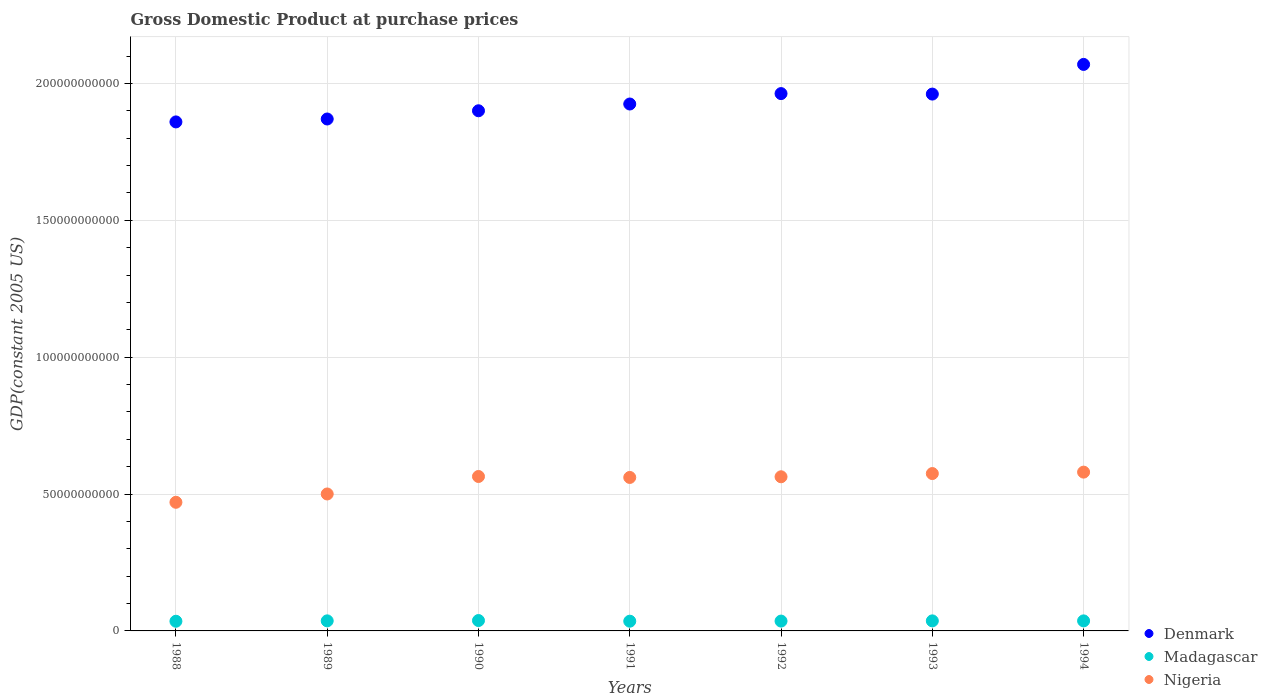How many different coloured dotlines are there?
Make the answer very short. 3. Is the number of dotlines equal to the number of legend labels?
Your answer should be very brief. Yes. What is the GDP at purchase prices in Nigeria in 1989?
Keep it short and to the point. 5.00e+1. Across all years, what is the maximum GDP at purchase prices in Nigeria?
Make the answer very short. 5.80e+1. Across all years, what is the minimum GDP at purchase prices in Madagascar?
Provide a short and direct response. 3.53e+09. In which year was the GDP at purchase prices in Madagascar maximum?
Your answer should be compact. 1990. What is the total GDP at purchase prices in Nigeria in the graph?
Offer a terse response. 3.81e+11. What is the difference between the GDP at purchase prices in Nigeria in 1988 and that in 1993?
Your answer should be compact. -1.05e+1. What is the difference between the GDP at purchase prices in Nigeria in 1994 and the GDP at purchase prices in Madagascar in 1992?
Your response must be concise. 5.44e+1. What is the average GDP at purchase prices in Denmark per year?
Your answer should be very brief. 1.94e+11. In the year 1992, what is the difference between the GDP at purchase prices in Nigeria and GDP at purchase prices in Denmark?
Keep it short and to the point. -1.40e+11. What is the ratio of the GDP at purchase prices in Nigeria in 1991 to that in 1992?
Your response must be concise. 1. Is the difference between the GDP at purchase prices in Nigeria in 1988 and 1990 greater than the difference between the GDP at purchase prices in Denmark in 1988 and 1990?
Offer a very short reply. No. What is the difference between the highest and the second highest GDP at purchase prices in Madagascar?
Keep it short and to the point. 1.15e+08. What is the difference between the highest and the lowest GDP at purchase prices in Denmark?
Give a very brief answer. 2.10e+1. In how many years, is the GDP at purchase prices in Madagascar greater than the average GDP at purchase prices in Madagascar taken over all years?
Provide a succinct answer. 4. Is the sum of the GDP at purchase prices in Nigeria in 1989 and 1992 greater than the maximum GDP at purchase prices in Denmark across all years?
Give a very brief answer. No. Is the GDP at purchase prices in Madagascar strictly greater than the GDP at purchase prices in Nigeria over the years?
Your answer should be compact. No. Is the GDP at purchase prices in Madagascar strictly less than the GDP at purchase prices in Nigeria over the years?
Provide a short and direct response. Yes. How many years are there in the graph?
Offer a terse response. 7. What is the difference between two consecutive major ticks on the Y-axis?
Provide a succinct answer. 5.00e+1. Does the graph contain grids?
Offer a very short reply. Yes. What is the title of the graph?
Offer a very short reply. Gross Domestic Product at purchase prices. Does "Pakistan" appear as one of the legend labels in the graph?
Provide a succinct answer. No. What is the label or title of the X-axis?
Keep it short and to the point. Years. What is the label or title of the Y-axis?
Provide a short and direct response. GDP(constant 2005 US). What is the GDP(constant 2005 US) in Denmark in 1988?
Give a very brief answer. 1.86e+11. What is the GDP(constant 2005 US) in Madagascar in 1988?
Give a very brief answer. 3.53e+09. What is the GDP(constant 2005 US) of Nigeria in 1988?
Ensure brevity in your answer.  4.70e+1. What is the GDP(constant 2005 US) in Denmark in 1989?
Offer a very short reply. 1.87e+11. What is the GDP(constant 2005 US) of Madagascar in 1989?
Your response must be concise. 3.68e+09. What is the GDP(constant 2005 US) in Nigeria in 1989?
Your response must be concise. 5.00e+1. What is the GDP(constant 2005 US) in Denmark in 1990?
Ensure brevity in your answer.  1.90e+11. What is the GDP(constant 2005 US) of Madagascar in 1990?
Ensure brevity in your answer.  3.79e+09. What is the GDP(constant 2005 US) in Nigeria in 1990?
Give a very brief answer. 5.64e+1. What is the GDP(constant 2005 US) of Denmark in 1991?
Offer a very short reply. 1.93e+11. What is the GDP(constant 2005 US) in Madagascar in 1991?
Ensure brevity in your answer.  3.55e+09. What is the GDP(constant 2005 US) in Nigeria in 1991?
Provide a succinct answer. 5.61e+1. What is the GDP(constant 2005 US) of Denmark in 1992?
Make the answer very short. 1.96e+11. What is the GDP(constant 2005 US) of Madagascar in 1992?
Your response must be concise. 3.60e+09. What is the GDP(constant 2005 US) of Nigeria in 1992?
Your answer should be very brief. 5.63e+1. What is the GDP(constant 2005 US) of Denmark in 1993?
Give a very brief answer. 1.96e+11. What is the GDP(constant 2005 US) in Madagascar in 1993?
Keep it short and to the point. 3.67e+09. What is the GDP(constant 2005 US) of Nigeria in 1993?
Offer a terse response. 5.75e+1. What is the GDP(constant 2005 US) of Denmark in 1994?
Your response must be concise. 2.07e+11. What is the GDP(constant 2005 US) of Madagascar in 1994?
Make the answer very short. 3.67e+09. What is the GDP(constant 2005 US) of Nigeria in 1994?
Keep it short and to the point. 5.80e+1. Across all years, what is the maximum GDP(constant 2005 US) in Denmark?
Provide a succinct answer. 2.07e+11. Across all years, what is the maximum GDP(constant 2005 US) of Madagascar?
Make the answer very short. 3.79e+09. Across all years, what is the maximum GDP(constant 2005 US) in Nigeria?
Your answer should be very brief. 5.80e+1. Across all years, what is the minimum GDP(constant 2005 US) of Denmark?
Your response must be concise. 1.86e+11. Across all years, what is the minimum GDP(constant 2005 US) of Madagascar?
Provide a short and direct response. 3.53e+09. Across all years, what is the minimum GDP(constant 2005 US) in Nigeria?
Offer a very short reply. 4.70e+1. What is the total GDP(constant 2005 US) in Denmark in the graph?
Give a very brief answer. 1.35e+12. What is the total GDP(constant 2005 US) of Madagascar in the graph?
Provide a succinct answer. 2.55e+1. What is the total GDP(constant 2005 US) of Nigeria in the graph?
Give a very brief answer. 3.81e+11. What is the difference between the GDP(constant 2005 US) in Denmark in 1988 and that in 1989?
Your answer should be compact. -1.07e+09. What is the difference between the GDP(constant 2005 US) of Madagascar in 1988 and that in 1989?
Your answer should be very brief. -1.44e+08. What is the difference between the GDP(constant 2005 US) in Nigeria in 1988 and that in 1989?
Ensure brevity in your answer.  -3.04e+09. What is the difference between the GDP(constant 2005 US) of Denmark in 1988 and that in 1990?
Your answer should be very brief. -4.07e+09. What is the difference between the GDP(constant 2005 US) in Madagascar in 1988 and that in 1990?
Offer a very short reply. -2.59e+08. What is the difference between the GDP(constant 2005 US) of Nigeria in 1988 and that in 1990?
Ensure brevity in your answer.  -9.43e+09. What is the difference between the GDP(constant 2005 US) of Denmark in 1988 and that in 1991?
Make the answer very short. -6.54e+09. What is the difference between the GDP(constant 2005 US) in Madagascar in 1988 and that in 1991?
Offer a terse response. -1.99e+07. What is the difference between the GDP(constant 2005 US) of Nigeria in 1988 and that in 1991?
Your response must be concise. -9.08e+09. What is the difference between the GDP(constant 2005 US) of Denmark in 1988 and that in 1992?
Your response must be concise. -1.03e+1. What is the difference between the GDP(constant 2005 US) in Madagascar in 1988 and that in 1992?
Ensure brevity in your answer.  -6.21e+07. What is the difference between the GDP(constant 2005 US) in Nigeria in 1988 and that in 1992?
Provide a succinct answer. -9.32e+09. What is the difference between the GDP(constant 2005 US) of Denmark in 1988 and that in 1993?
Offer a terse response. -1.02e+1. What is the difference between the GDP(constant 2005 US) of Madagascar in 1988 and that in 1993?
Give a very brief answer. -1.37e+08. What is the difference between the GDP(constant 2005 US) in Nigeria in 1988 and that in 1993?
Your response must be concise. -1.05e+1. What is the difference between the GDP(constant 2005 US) of Denmark in 1988 and that in 1994?
Provide a short and direct response. -2.10e+1. What is the difference between the GDP(constant 2005 US) of Madagascar in 1988 and that in 1994?
Your response must be concise. -1.35e+08. What is the difference between the GDP(constant 2005 US) of Nigeria in 1988 and that in 1994?
Keep it short and to the point. -1.10e+1. What is the difference between the GDP(constant 2005 US) in Denmark in 1989 and that in 1990?
Give a very brief answer. -3.01e+09. What is the difference between the GDP(constant 2005 US) in Madagascar in 1989 and that in 1990?
Ensure brevity in your answer.  -1.15e+08. What is the difference between the GDP(constant 2005 US) of Nigeria in 1989 and that in 1990?
Your response must be concise. -6.39e+09. What is the difference between the GDP(constant 2005 US) in Denmark in 1989 and that in 1991?
Offer a very short reply. -5.48e+09. What is the difference between the GDP(constant 2005 US) of Madagascar in 1989 and that in 1991?
Ensure brevity in your answer.  1.24e+08. What is the difference between the GDP(constant 2005 US) in Nigeria in 1989 and that in 1991?
Your answer should be compact. -6.04e+09. What is the difference between the GDP(constant 2005 US) of Denmark in 1989 and that in 1992?
Your response must be concise. -9.28e+09. What is the difference between the GDP(constant 2005 US) of Madagascar in 1989 and that in 1992?
Your response must be concise. 8.20e+07. What is the difference between the GDP(constant 2005 US) of Nigeria in 1989 and that in 1992?
Provide a succinct answer. -6.28e+09. What is the difference between the GDP(constant 2005 US) in Denmark in 1989 and that in 1993?
Keep it short and to the point. -9.10e+09. What is the difference between the GDP(constant 2005 US) in Madagascar in 1989 and that in 1993?
Your answer should be compact. 6.66e+06. What is the difference between the GDP(constant 2005 US) in Nigeria in 1989 and that in 1993?
Ensure brevity in your answer.  -7.46e+09. What is the difference between the GDP(constant 2005 US) in Denmark in 1989 and that in 1994?
Provide a succinct answer. -1.99e+1. What is the difference between the GDP(constant 2005 US) in Madagascar in 1989 and that in 1994?
Provide a succinct answer. 9.29e+06. What is the difference between the GDP(constant 2005 US) in Nigeria in 1989 and that in 1994?
Your response must be concise. -7.98e+09. What is the difference between the GDP(constant 2005 US) of Denmark in 1990 and that in 1991?
Provide a succinct answer. -2.47e+09. What is the difference between the GDP(constant 2005 US) in Madagascar in 1990 and that in 1991?
Provide a succinct answer. 2.39e+08. What is the difference between the GDP(constant 2005 US) of Nigeria in 1990 and that in 1991?
Make the answer very short. 3.49e+08. What is the difference between the GDP(constant 2005 US) in Denmark in 1990 and that in 1992?
Provide a succinct answer. -6.27e+09. What is the difference between the GDP(constant 2005 US) in Madagascar in 1990 and that in 1992?
Your response must be concise. 1.97e+08. What is the difference between the GDP(constant 2005 US) in Nigeria in 1990 and that in 1992?
Your response must be concise. 1.05e+08. What is the difference between the GDP(constant 2005 US) in Denmark in 1990 and that in 1993?
Make the answer very short. -6.10e+09. What is the difference between the GDP(constant 2005 US) of Madagascar in 1990 and that in 1993?
Make the answer very short. 1.22e+08. What is the difference between the GDP(constant 2005 US) of Nigeria in 1990 and that in 1993?
Your response must be concise. -1.07e+09. What is the difference between the GDP(constant 2005 US) in Denmark in 1990 and that in 1994?
Ensure brevity in your answer.  -1.69e+1. What is the difference between the GDP(constant 2005 US) of Madagascar in 1990 and that in 1994?
Your answer should be very brief. 1.24e+08. What is the difference between the GDP(constant 2005 US) in Nigeria in 1990 and that in 1994?
Give a very brief answer. -1.59e+09. What is the difference between the GDP(constant 2005 US) of Denmark in 1991 and that in 1992?
Your answer should be very brief. -3.80e+09. What is the difference between the GDP(constant 2005 US) in Madagascar in 1991 and that in 1992?
Provide a succinct answer. -4.21e+07. What is the difference between the GDP(constant 2005 US) in Nigeria in 1991 and that in 1992?
Provide a succinct answer. -2.43e+08. What is the difference between the GDP(constant 2005 US) in Denmark in 1991 and that in 1993?
Provide a succinct answer. -3.63e+09. What is the difference between the GDP(constant 2005 US) in Madagascar in 1991 and that in 1993?
Ensure brevity in your answer.  -1.18e+08. What is the difference between the GDP(constant 2005 US) of Nigeria in 1991 and that in 1993?
Your answer should be compact. -1.42e+09. What is the difference between the GDP(constant 2005 US) in Denmark in 1991 and that in 1994?
Give a very brief answer. -1.45e+1. What is the difference between the GDP(constant 2005 US) of Madagascar in 1991 and that in 1994?
Your answer should be compact. -1.15e+08. What is the difference between the GDP(constant 2005 US) of Nigeria in 1991 and that in 1994?
Make the answer very short. -1.94e+09. What is the difference between the GDP(constant 2005 US) in Denmark in 1992 and that in 1993?
Keep it short and to the point. 1.76e+08. What is the difference between the GDP(constant 2005 US) in Madagascar in 1992 and that in 1993?
Make the answer very short. -7.54e+07. What is the difference between the GDP(constant 2005 US) of Nigeria in 1992 and that in 1993?
Your answer should be compact. -1.18e+09. What is the difference between the GDP(constant 2005 US) in Denmark in 1992 and that in 1994?
Provide a succinct answer. -1.07e+1. What is the difference between the GDP(constant 2005 US) of Madagascar in 1992 and that in 1994?
Provide a short and direct response. -7.27e+07. What is the difference between the GDP(constant 2005 US) in Nigeria in 1992 and that in 1994?
Your answer should be compact. -1.70e+09. What is the difference between the GDP(constant 2005 US) in Denmark in 1993 and that in 1994?
Offer a very short reply. -1.08e+1. What is the difference between the GDP(constant 2005 US) in Madagascar in 1993 and that in 1994?
Make the answer very short. 2.63e+06. What is the difference between the GDP(constant 2005 US) in Nigeria in 1993 and that in 1994?
Offer a terse response. -5.23e+08. What is the difference between the GDP(constant 2005 US) of Denmark in 1988 and the GDP(constant 2005 US) of Madagascar in 1989?
Provide a succinct answer. 1.82e+11. What is the difference between the GDP(constant 2005 US) in Denmark in 1988 and the GDP(constant 2005 US) in Nigeria in 1989?
Give a very brief answer. 1.36e+11. What is the difference between the GDP(constant 2005 US) in Madagascar in 1988 and the GDP(constant 2005 US) in Nigeria in 1989?
Provide a succinct answer. -4.65e+1. What is the difference between the GDP(constant 2005 US) in Denmark in 1988 and the GDP(constant 2005 US) in Madagascar in 1990?
Give a very brief answer. 1.82e+11. What is the difference between the GDP(constant 2005 US) of Denmark in 1988 and the GDP(constant 2005 US) of Nigeria in 1990?
Your response must be concise. 1.30e+11. What is the difference between the GDP(constant 2005 US) in Madagascar in 1988 and the GDP(constant 2005 US) in Nigeria in 1990?
Keep it short and to the point. -5.29e+1. What is the difference between the GDP(constant 2005 US) in Denmark in 1988 and the GDP(constant 2005 US) in Madagascar in 1991?
Ensure brevity in your answer.  1.82e+11. What is the difference between the GDP(constant 2005 US) in Denmark in 1988 and the GDP(constant 2005 US) in Nigeria in 1991?
Provide a succinct answer. 1.30e+11. What is the difference between the GDP(constant 2005 US) of Madagascar in 1988 and the GDP(constant 2005 US) of Nigeria in 1991?
Your answer should be very brief. -5.25e+1. What is the difference between the GDP(constant 2005 US) of Denmark in 1988 and the GDP(constant 2005 US) of Madagascar in 1992?
Ensure brevity in your answer.  1.82e+11. What is the difference between the GDP(constant 2005 US) of Denmark in 1988 and the GDP(constant 2005 US) of Nigeria in 1992?
Give a very brief answer. 1.30e+11. What is the difference between the GDP(constant 2005 US) in Madagascar in 1988 and the GDP(constant 2005 US) in Nigeria in 1992?
Keep it short and to the point. -5.28e+1. What is the difference between the GDP(constant 2005 US) of Denmark in 1988 and the GDP(constant 2005 US) of Madagascar in 1993?
Offer a terse response. 1.82e+11. What is the difference between the GDP(constant 2005 US) in Denmark in 1988 and the GDP(constant 2005 US) in Nigeria in 1993?
Your answer should be very brief. 1.28e+11. What is the difference between the GDP(constant 2005 US) in Madagascar in 1988 and the GDP(constant 2005 US) in Nigeria in 1993?
Your response must be concise. -5.40e+1. What is the difference between the GDP(constant 2005 US) of Denmark in 1988 and the GDP(constant 2005 US) of Madagascar in 1994?
Give a very brief answer. 1.82e+11. What is the difference between the GDP(constant 2005 US) in Denmark in 1988 and the GDP(constant 2005 US) in Nigeria in 1994?
Your response must be concise. 1.28e+11. What is the difference between the GDP(constant 2005 US) in Madagascar in 1988 and the GDP(constant 2005 US) in Nigeria in 1994?
Offer a very short reply. -5.45e+1. What is the difference between the GDP(constant 2005 US) of Denmark in 1989 and the GDP(constant 2005 US) of Madagascar in 1990?
Your answer should be very brief. 1.83e+11. What is the difference between the GDP(constant 2005 US) of Denmark in 1989 and the GDP(constant 2005 US) of Nigeria in 1990?
Provide a succinct answer. 1.31e+11. What is the difference between the GDP(constant 2005 US) in Madagascar in 1989 and the GDP(constant 2005 US) in Nigeria in 1990?
Ensure brevity in your answer.  -5.27e+1. What is the difference between the GDP(constant 2005 US) in Denmark in 1989 and the GDP(constant 2005 US) in Madagascar in 1991?
Offer a terse response. 1.83e+11. What is the difference between the GDP(constant 2005 US) of Denmark in 1989 and the GDP(constant 2005 US) of Nigeria in 1991?
Provide a short and direct response. 1.31e+11. What is the difference between the GDP(constant 2005 US) of Madagascar in 1989 and the GDP(constant 2005 US) of Nigeria in 1991?
Ensure brevity in your answer.  -5.24e+1. What is the difference between the GDP(constant 2005 US) in Denmark in 1989 and the GDP(constant 2005 US) in Madagascar in 1992?
Your answer should be very brief. 1.83e+11. What is the difference between the GDP(constant 2005 US) in Denmark in 1989 and the GDP(constant 2005 US) in Nigeria in 1992?
Give a very brief answer. 1.31e+11. What is the difference between the GDP(constant 2005 US) of Madagascar in 1989 and the GDP(constant 2005 US) of Nigeria in 1992?
Keep it short and to the point. -5.26e+1. What is the difference between the GDP(constant 2005 US) in Denmark in 1989 and the GDP(constant 2005 US) in Madagascar in 1993?
Offer a very short reply. 1.83e+11. What is the difference between the GDP(constant 2005 US) in Denmark in 1989 and the GDP(constant 2005 US) in Nigeria in 1993?
Your response must be concise. 1.30e+11. What is the difference between the GDP(constant 2005 US) in Madagascar in 1989 and the GDP(constant 2005 US) in Nigeria in 1993?
Provide a short and direct response. -5.38e+1. What is the difference between the GDP(constant 2005 US) in Denmark in 1989 and the GDP(constant 2005 US) in Madagascar in 1994?
Provide a short and direct response. 1.83e+11. What is the difference between the GDP(constant 2005 US) in Denmark in 1989 and the GDP(constant 2005 US) in Nigeria in 1994?
Provide a short and direct response. 1.29e+11. What is the difference between the GDP(constant 2005 US) of Madagascar in 1989 and the GDP(constant 2005 US) of Nigeria in 1994?
Ensure brevity in your answer.  -5.43e+1. What is the difference between the GDP(constant 2005 US) in Denmark in 1990 and the GDP(constant 2005 US) in Madagascar in 1991?
Keep it short and to the point. 1.86e+11. What is the difference between the GDP(constant 2005 US) in Denmark in 1990 and the GDP(constant 2005 US) in Nigeria in 1991?
Provide a short and direct response. 1.34e+11. What is the difference between the GDP(constant 2005 US) in Madagascar in 1990 and the GDP(constant 2005 US) in Nigeria in 1991?
Make the answer very short. -5.23e+1. What is the difference between the GDP(constant 2005 US) in Denmark in 1990 and the GDP(constant 2005 US) in Madagascar in 1992?
Your answer should be very brief. 1.86e+11. What is the difference between the GDP(constant 2005 US) of Denmark in 1990 and the GDP(constant 2005 US) of Nigeria in 1992?
Offer a terse response. 1.34e+11. What is the difference between the GDP(constant 2005 US) in Madagascar in 1990 and the GDP(constant 2005 US) in Nigeria in 1992?
Keep it short and to the point. -5.25e+1. What is the difference between the GDP(constant 2005 US) in Denmark in 1990 and the GDP(constant 2005 US) in Madagascar in 1993?
Keep it short and to the point. 1.86e+11. What is the difference between the GDP(constant 2005 US) in Denmark in 1990 and the GDP(constant 2005 US) in Nigeria in 1993?
Keep it short and to the point. 1.33e+11. What is the difference between the GDP(constant 2005 US) of Madagascar in 1990 and the GDP(constant 2005 US) of Nigeria in 1993?
Your answer should be compact. -5.37e+1. What is the difference between the GDP(constant 2005 US) of Denmark in 1990 and the GDP(constant 2005 US) of Madagascar in 1994?
Provide a short and direct response. 1.86e+11. What is the difference between the GDP(constant 2005 US) of Denmark in 1990 and the GDP(constant 2005 US) of Nigeria in 1994?
Keep it short and to the point. 1.32e+11. What is the difference between the GDP(constant 2005 US) of Madagascar in 1990 and the GDP(constant 2005 US) of Nigeria in 1994?
Provide a short and direct response. -5.42e+1. What is the difference between the GDP(constant 2005 US) of Denmark in 1991 and the GDP(constant 2005 US) of Madagascar in 1992?
Your answer should be very brief. 1.89e+11. What is the difference between the GDP(constant 2005 US) in Denmark in 1991 and the GDP(constant 2005 US) in Nigeria in 1992?
Provide a short and direct response. 1.36e+11. What is the difference between the GDP(constant 2005 US) in Madagascar in 1991 and the GDP(constant 2005 US) in Nigeria in 1992?
Make the answer very short. -5.28e+1. What is the difference between the GDP(constant 2005 US) of Denmark in 1991 and the GDP(constant 2005 US) of Madagascar in 1993?
Ensure brevity in your answer.  1.89e+11. What is the difference between the GDP(constant 2005 US) in Denmark in 1991 and the GDP(constant 2005 US) in Nigeria in 1993?
Keep it short and to the point. 1.35e+11. What is the difference between the GDP(constant 2005 US) in Madagascar in 1991 and the GDP(constant 2005 US) in Nigeria in 1993?
Provide a succinct answer. -5.39e+1. What is the difference between the GDP(constant 2005 US) in Denmark in 1991 and the GDP(constant 2005 US) in Madagascar in 1994?
Your answer should be very brief. 1.89e+11. What is the difference between the GDP(constant 2005 US) in Denmark in 1991 and the GDP(constant 2005 US) in Nigeria in 1994?
Offer a very short reply. 1.34e+11. What is the difference between the GDP(constant 2005 US) of Madagascar in 1991 and the GDP(constant 2005 US) of Nigeria in 1994?
Your answer should be compact. -5.45e+1. What is the difference between the GDP(constant 2005 US) of Denmark in 1992 and the GDP(constant 2005 US) of Madagascar in 1993?
Offer a very short reply. 1.93e+11. What is the difference between the GDP(constant 2005 US) of Denmark in 1992 and the GDP(constant 2005 US) of Nigeria in 1993?
Keep it short and to the point. 1.39e+11. What is the difference between the GDP(constant 2005 US) in Madagascar in 1992 and the GDP(constant 2005 US) in Nigeria in 1993?
Ensure brevity in your answer.  -5.39e+1. What is the difference between the GDP(constant 2005 US) in Denmark in 1992 and the GDP(constant 2005 US) in Madagascar in 1994?
Your answer should be very brief. 1.93e+11. What is the difference between the GDP(constant 2005 US) in Denmark in 1992 and the GDP(constant 2005 US) in Nigeria in 1994?
Keep it short and to the point. 1.38e+11. What is the difference between the GDP(constant 2005 US) in Madagascar in 1992 and the GDP(constant 2005 US) in Nigeria in 1994?
Make the answer very short. -5.44e+1. What is the difference between the GDP(constant 2005 US) of Denmark in 1993 and the GDP(constant 2005 US) of Madagascar in 1994?
Make the answer very short. 1.92e+11. What is the difference between the GDP(constant 2005 US) of Denmark in 1993 and the GDP(constant 2005 US) of Nigeria in 1994?
Offer a terse response. 1.38e+11. What is the difference between the GDP(constant 2005 US) in Madagascar in 1993 and the GDP(constant 2005 US) in Nigeria in 1994?
Give a very brief answer. -5.43e+1. What is the average GDP(constant 2005 US) in Denmark per year?
Ensure brevity in your answer.  1.94e+11. What is the average GDP(constant 2005 US) of Madagascar per year?
Keep it short and to the point. 3.64e+09. What is the average GDP(constant 2005 US) in Nigeria per year?
Provide a short and direct response. 5.45e+1. In the year 1988, what is the difference between the GDP(constant 2005 US) in Denmark and GDP(constant 2005 US) in Madagascar?
Your answer should be very brief. 1.82e+11. In the year 1988, what is the difference between the GDP(constant 2005 US) in Denmark and GDP(constant 2005 US) in Nigeria?
Your answer should be very brief. 1.39e+11. In the year 1988, what is the difference between the GDP(constant 2005 US) in Madagascar and GDP(constant 2005 US) in Nigeria?
Make the answer very short. -4.35e+1. In the year 1989, what is the difference between the GDP(constant 2005 US) in Denmark and GDP(constant 2005 US) in Madagascar?
Your answer should be very brief. 1.83e+11. In the year 1989, what is the difference between the GDP(constant 2005 US) of Denmark and GDP(constant 2005 US) of Nigeria?
Offer a terse response. 1.37e+11. In the year 1989, what is the difference between the GDP(constant 2005 US) of Madagascar and GDP(constant 2005 US) of Nigeria?
Your answer should be compact. -4.64e+1. In the year 1990, what is the difference between the GDP(constant 2005 US) in Denmark and GDP(constant 2005 US) in Madagascar?
Your answer should be very brief. 1.86e+11. In the year 1990, what is the difference between the GDP(constant 2005 US) in Denmark and GDP(constant 2005 US) in Nigeria?
Your answer should be very brief. 1.34e+11. In the year 1990, what is the difference between the GDP(constant 2005 US) in Madagascar and GDP(constant 2005 US) in Nigeria?
Provide a succinct answer. -5.26e+1. In the year 1991, what is the difference between the GDP(constant 2005 US) in Denmark and GDP(constant 2005 US) in Madagascar?
Make the answer very short. 1.89e+11. In the year 1991, what is the difference between the GDP(constant 2005 US) of Denmark and GDP(constant 2005 US) of Nigeria?
Give a very brief answer. 1.36e+11. In the year 1991, what is the difference between the GDP(constant 2005 US) of Madagascar and GDP(constant 2005 US) of Nigeria?
Provide a succinct answer. -5.25e+1. In the year 1992, what is the difference between the GDP(constant 2005 US) in Denmark and GDP(constant 2005 US) in Madagascar?
Make the answer very short. 1.93e+11. In the year 1992, what is the difference between the GDP(constant 2005 US) of Denmark and GDP(constant 2005 US) of Nigeria?
Provide a short and direct response. 1.40e+11. In the year 1992, what is the difference between the GDP(constant 2005 US) of Madagascar and GDP(constant 2005 US) of Nigeria?
Provide a short and direct response. -5.27e+1. In the year 1993, what is the difference between the GDP(constant 2005 US) in Denmark and GDP(constant 2005 US) in Madagascar?
Keep it short and to the point. 1.92e+11. In the year 1993, what is the difference between the GDP(constant 2005 US) of Denmark and GDP(constant 2005 US) of Nigeria?
Provide a short and direct response. 1.39e+11. In the year 1993, what is the difference between the GDP(constant 2005 US) in Madagascar and GDP(constant 2005 US) in Nigeria?
Provide a succinct answer. -5.38e+1. In the year 1994, what is the difference between the GDP(constant 2005 US) of Denmark and GDP(constant 2005 US) of Madagascar?
Your answer should be compact. 2.03e+11. In the year 1994, what is the difference between the GDP(constant 2005 US) in Denmark and GDP(constant 2005 US) in Nigeria?
Provide a succinct answer. 1.49e+11. In the year 1994, what is the difference between the GDP(constant 2005 US) in Madagascar and GDP(constant 2005 US) in Nigeria?
Provide a succinct answer. -5.43e+1. What is the ratio of the GDP(constant 2005 US) in Madagascar in 1988 to that in 1989?
Your response must be concise. 0.96. What is the ratio of the GDP(constant 2005 US) in Nigeria in 1988 to that in 1989?
Your response must be concise. 0.94. What is the ratio of the GDP(constant 2005 US) of Denmark in 1988 to that in 1990?
Give a very brief answer. 0.98. What is the ratio of the GDP(constant 2005 US) of Madagascar in 1988 to that in 1990?
Keep it short and to the point. 0.93. What is the ratio of the GDP(constant 2005 US) of Nigeria in 1988 to that in 1990?
Offer a very short reply. 0.83. What is the ratio of the GDP(constant 2005 US) in Madagascar in 1988 to that in 1991?
Offer a terse response. 0.99. What is the ratio of the GDP(constant 2005 US) in Nigeria in 1988 to that in 1991?
Ensure brevity in your answer.  0.84. What is the ratio of the GDP(constant 2005 US) in Denmark in 1988 to that in 1992?
Offer a very short reply. 0.95. What is the ratio of the GDP(constant 2005 US) in Madagascar in 1988 to that in 1992?
Give a very brief answer. 0.98. What is the ratio of the GDP(constant 2005 US) in Nigeria in 1988 to that in 1992?
Your answer should be very brief. 0.83. What is the ratio of the GDP(constant 2005 US) of Denmark in 1988 to that in 1993?
Ensure brevity in your answer.  0.95. What is the ratio of the GDP(constant 2005 US) of Madagascar in 1988 to that in 1993?
Make the answer very short. 0.96. What is the ratio of the GDP(constant 2005 US) of Nigeria in 1988 to that in 1993?
Keep it short and to the point. 0.82. What is the ratio of the GDP(constant 2005 US) of Denmark in 1988 to that in 1994?
Ensure brevity in your answer.  0.9. What is the ratio of the GDP(constant 2005 US) of Madagascar in 1988 to that in 1994?
Keep it short and to the point. 0.96. What is the ratio of the GDP(constant 2005 US) in Nigeria in 1988 to that in 1994?
Provide a short and direct response. 0.81. What is the ratio of the GDP(constant 2005 US) of Denmark in 1989 to that in 1990?
Offer a very short reply. 0.98. What is the ratio of the GDP(constant 2005 US) of Madagascar in 1989 to that in 1990?
Make the answer very short. 0.97. What is the ratio of the GDP(constant 2005 US) of Nigeria in 1989 to that in 1990?
Ensure brevity in your answer.  0.89. What is the ratio of the GDP(constant 2005 US) in Denmark in 1989 to that in 1991?
Provide a succinct answer. 0.97. What is the ratio of the GDP(constant 2005 US) in Madagascar in 1989 to that in 1991?
Give a very brief answer. 1.03. What is the ratio of the GDP(constant 2005 US) in Nigeria in 1989 to that in 1991?
Your answer should be very brief. 0.89. What is the ratio of the GDP(constant 2005 US) of Denmark in 1989 to that in 1992?
Make the answer very short. 0.95. What is the ratio of the GDP(constant 2005 US) in Madagascar in 1989 to that in 1992?
Your answer should be very brief. 1.02. What is the ratio of the GDP(constant 2005 US) in Nigeria in 1989 to that in 1992?
Offer a very short reply. 0.89. What is the ratio of the GDP(constant 2005 US) of Denmark in 1989 to that in 1993?
Keep it short and to the point. 0.95. What is the ratio of the GDP(constant 2005 US) of Nigeria in 1989 to that in 1993?
Give a very brief answer. 0.87. What is the ratio of the GDP(constant 2005 US) in Denmark in 1989 to that in 1994?
Offer a terse response. 0.9. What is the ratio of the GDP(constant 2005 US) in Nigeria in 1989 to that in 1994?
Give a very brief answer. 0.86. What is the ratio of the GDP(constant 2005 US) in Denmark in 1990 to that in 1991?
Your answer should be compact. 0.99. What is the ratio of the GDP(constant 2005 US) of Madagascar in 1990 to that in 1991?
Offer a very short reply. 1.07. What is the ratio of the GDP(constant 2005 US) of Nigeria in 1990 to that in 1991?
Your answer should be very brief. 1.01. What is the ratio of the GDP(constant 2005 US) of Madagascar in 1990 to that in 1992?
Give a very brief answer. 1.05. What is the ratio of the GDP(constant 2005 US) in Denmark in 1990 to that in 1993?
Keep it short and to the point. 0.97. What is the ratio of the GDP(constant 2005 US) of Madagascar in 1990 to that in 1993?
Provide a short and direct response. 1.03. What is the ratio of the GDP(constant 2005 US) in Nigeria in 1990 to that in 1993?
Your answer should be compact. 0.98. What is the ratio of the GDP(constant 2005 US) in Denmark in 1990 to that in 1994?
Give a very brief answer. 0.92. What is the ratio of the GDP(constant 2005 US) of Madagascar in 1990 to that in 1994?
Provide a succinct answer. 1.03. What is the ratio of the GDP(constant 2005 US) in Nigeria in 1990 to that in 1994?
Your answer should be compact. 0.97. What is the ratio of the GDP(constant 2005 US) in Denmark in 1991 to that in 1992?
Provide a short and direct response. 0.98. What is the ratio of the GDP(constant 2005 US) of Madagascar in 1991 to that in 1992?
Ensure brevity in your answer.  0.99. What is the ratio of the GDP(constant 2005 US) of Denmark in 1991 to that in 1993?
Make the answer very short. 0.98. What is the ratio of the GDP(constant 2005 US) in Madagascar in 1991 to that in 1993?
Provide a succinct answer. 0.97. What is the ratio of the GDP(constant 2005 US) in Nigeria in 1991 to that in 1993?
Ensure brevity in your answer.  0.98. What is the ratio of the GDP(constant 2005 US) in Denmark in 1991 to that in 1994?
Keep it short and to the point. 0.93. What is the ratio of the GDP(constant 2005 US) of Madagascar in 1991 to that in 1994?
Make the answer very short. 0.97. What is the ratio of the GDP(constant 2005 US) in Nigeria in 1991 to that in 1994?
Your answer should be compact. 0.97. What is the ratio of the GDP(constant 2005 US) of Denmark in 1992 to that in 1993?
Offer a very short reply. 1. What is the ratio of the GDP(constant 2005 US) in Madagascar in 1992 to that in 1993?
Make the answer very short. 0.98. What is the ratio of the GDP(constant 2005 US) of Nigeria in 1992 to that in 1993?
Keep it short and to the point. 0.98. What is the ratio of the GDP(constant 2005 US) in Denmark in 1992 to that in 1994?
Provide a short and direct response. 0.95. What is the ratio of the GDP(constant 2005 US) in Madagascar in 1992 to that in 1994?
Your answer should be very brief. 0.98. What is the ratio of the GDP(constant 2005 US) of Nigeria in 1992 to that in 1994?
Make the answer very short. 0.97. What is the ratio of the GDP(constant 2005 US) of Denmark in 1993 to that in 1994?
Provide a short and direct response. 0.95. What is the ratio of the GDP(constant 2005 US) of Madagascar in 1993 to that in 1994?
Your response must be concise. 1. What is the difference between the highest and the second highest GDP(constant 2005 US) of Denmark?
Provide a short and direct response. 1.07e+1. What is the difference between the highest and the second highest GDP(constant 2005 US) in Madagascar?
Make the answer very short. 1.15e+08. What is the difference between the highest and the second highest GDP(constant 2005 US) of Nigeria?
Your answer should be compact. 5.23e+08. What is the difference between the highest and the lowest GDP(constant 2005 US) in Denmark?
Your answer should be very brief. 2.10e+1. What is the difference between the highest and the lowest GDP(constant 2005 US) of Madagascar?
Provide a succinct answer. 2.59e+08. What is the difference between the highest and the lowest GDP(constant 2005 US) of Nigeria?
Ensure brevity in your answer.  1.10e+1. 